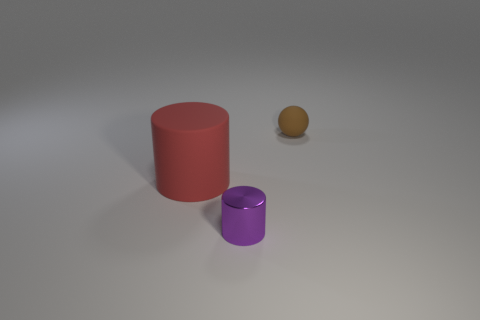Add 2 red rubber cylinders. How many objects exist? 5 Subtract 1 spheres. How many spheres are left? 0 Subtract all green blocks. How many purple cylinders are left? 1 Subtract all large red rubber things. Subtract all shiny cylinders. How many objects are left? 1 Add 3 balls. How many balls are left? 4 Add 1 large green metallic cylinders. How many large green metallic cylinders exist? 1 Subtract all red cylinders. How many cylinders are left? 1 Subtract 0 yellow cylinders. How many objects are left? 3 Subtract all cylinders. How many objects are left? 1 Subtract all red cylinders. Subtract all blue balls. How many cylinders are left? 1 